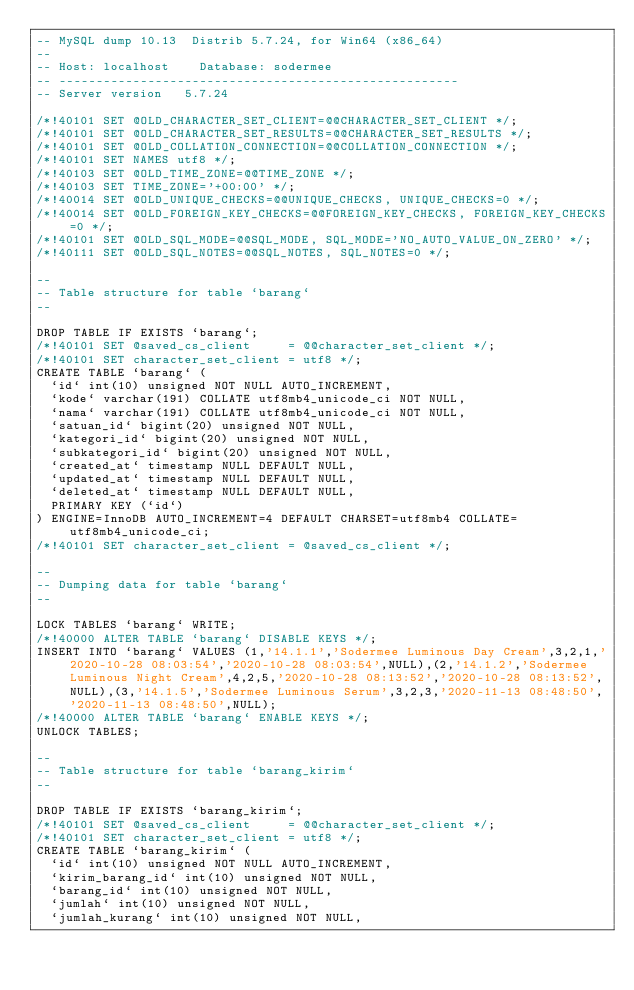<code> <loc_0><loc_0><loc_500><loc_500><_SQL_>-- MySQL dump 10.13  Distrib 5.7.24, for Win64 (x86_64)
--
-- Host: localhost    Database: sodermee
-- ------------------------------------------------------
-- Server version	5.7.24

/*!40101 SET @OLD_CHARACTER_SET_CLIENT=@@CHARACTER_SET_CLIENT */;
/*!40101 SET @OLD_CHARACTER_SET_RESULTS=@@CHARACTER_SET_RESULTS */;
/*!40101 SET @OLD_COLLATION_CONNECTION=@@COLLATION_CONNECTION */;
/*!40101 SET NAMES utf8 */;
/*!40103 SET @OLD_TIME_ZONE=@@TIME_ZONE */;
/*!40103 SET TIME_ZONE='+00:00' */;
/*!40014 SET @OLD_UNIQUE_CHECKS=@@UNIQUE_CHECKS, UNIQUE_CHECKS=0 */;
/*!40014 SET @OLD_FOREIGN_KEY_CHECKS=@@FOREIGN_KEY_CHECKS, FOREIGN_KEY_CHECKS=0 */;
/*!40101 SET @OLD_SQL_MODE=@@SQL_MODE, SQL_MODE='NO_AUTO_VALUE_ON_ZERO' */;
/*!40111 SET @OLD_SQL_NOTES=@@SQL_NOTES, SQL_NOTES=0 */;

--
-- Table structure for table `barang`
--

DROP TABLE IF EXISTS `barang`;
/*!40101 SET @saved_cs_client     = @@character_set_client */;
/*!40101 SET character_set_client = utf8 */;
CREATE TABLE `barang` (
  `id` int(10) unsigned NOT NULL AUTO_INCREMENT,
  `kode` varchar(191) COLLATE utf8mb4_unicode_ci NOT NULL,
  `nama` varchar(191) COLLATE utf8mb4_unicode_ci NOT NULL,
  `satuan_id` bigint(20) unsigned NOT NULL,
  `kategori_id` bigint(20) unsigned NOT NULL,
  `subkategori_id` bigint(20) unsigned NOT NULL,
  `created_at` timestamp NULL DEFAULT NULL,
  `updated_at` timestamp NULL DEFAULT NULL,
  `deleted_at` timestamp NULL DEFAULT NULL,
  PRIMARY KEY (`id`)
) ENGINE=InnoDB AUTO_INCREMENT=4 DEFAULT CHARSET=utf8mb4 COLLATE=utf8mb4_unicode_ci;
/*!40101 SET character_set_client = @saved_cs_client */;

--
-- Dumping data for table `barang`
--

LOCK TABLES `barang` WRITE;
/*!40000 ALTER TABLE `barang` DISABLE KEYS */;
INSERT INTO `barang` VALUES (1,'14.1.1','Sodermee Luminous Day Cream',3,2,1,'2020-10-28 08:03:54','2020-10-28 08:03:54',NULL),(2,'14.1.2','Sodermee Luminous Night Cream',4,2,5,'2020-10-28 08:13:52','2020-10-28 08:13:52',NULL),(3,'14.1.5','Sodermee Luminous Serum',3,2,3,'2020-11-13 08:48:50','2020-11-13 08:48:50',NULL);
/*!40000 ALTER TABLE `barang` ENABLE KEYS */;
UNLOCK TABLES;

--
-- Table structure for table `barang_kirim`
--

DROP TABLE IF EXISTS `barang_kirim`;
/*!40101 SET @saved_cs_client     = @@character_set_client */;
/*!40101 SET character_set_client = utf8 */;
CREATE TABLE `barang_kirim` (
  `id` int(10) unsigned NOT NULL AUTO_INCREMENT,
  `kirim_barang_id` int(10) unsigned NOT NULL,
  `barang_id` int(10) unsigned NOT NULL,
  `jumlah` int(10) unsigned NOT NULL,
  `jumlah_kurang` int(10) unsigned NOT NULL,</code> 